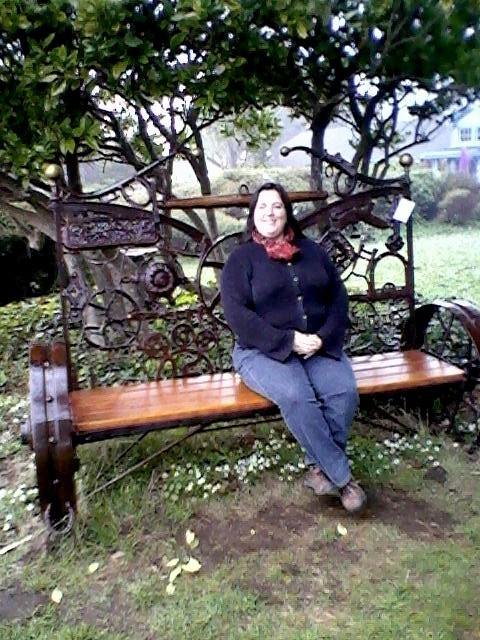Describe the objects in this image and their specific colors. I can see bench in darkgreen, black, gray, lightgray, and darkgray tones and people in darkgreen, black, navy, and gray tones in this image. 